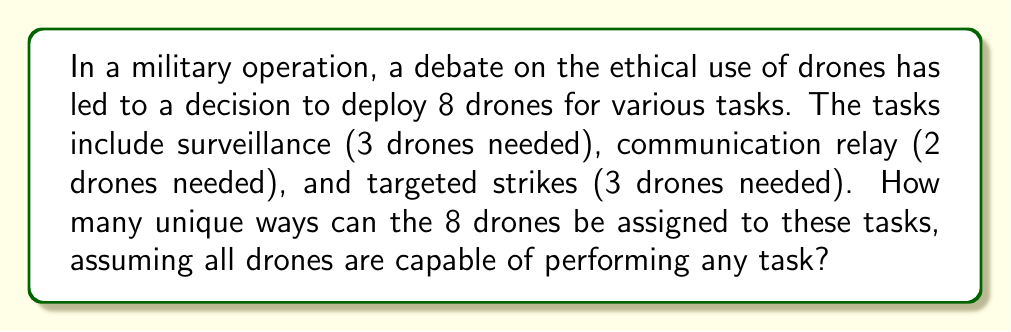What is the answer to this math problem? To solve this problem, we need to use the concept of permutations with repetition. Here's a step-by-step explanation:

1) We have 8 identical drones that need to be distributed among 3 different tasks.

2) This scenario is equivalent to arranging 8 identical objects into 3 distinct groups, where the order within each group doesn't matter.

3) This type of problem can be solved using the "Stars and Bars" method, also known as the "Balls and Urns" problem.

4) The formula for this scenario is:

   $$\binom{n+k-1}{k-1}$$

   where $n$ is the number of identical objects (drones in this case) and $k$ is the number of distinct groups (tasks in this case).

5) In our problem:
   $n = 8$ (drones)
   $k = 3$ (tasks)

6) Plugging these values into the formula:

   $$\binom{8+3-1}{3-1} = \binom{10}{2}$$

7) We can calculate this combination:

   $$\binom{10}{2} = \frac{10!}{2!(10-2)!} = \frac{10!}{2!8!} = \frac{10 \cdot 9}{2 \cdot 1} = 45$$

Therefore, there are 45 unique ways to assign the drones to the tasks.

Note: This solution assumes that we only care about the number of drones assigned to each task, not which specific drone goes to which task. If we needed to consider specific drone assignments, we would use a different approach.
Answer: 45 unique ways 